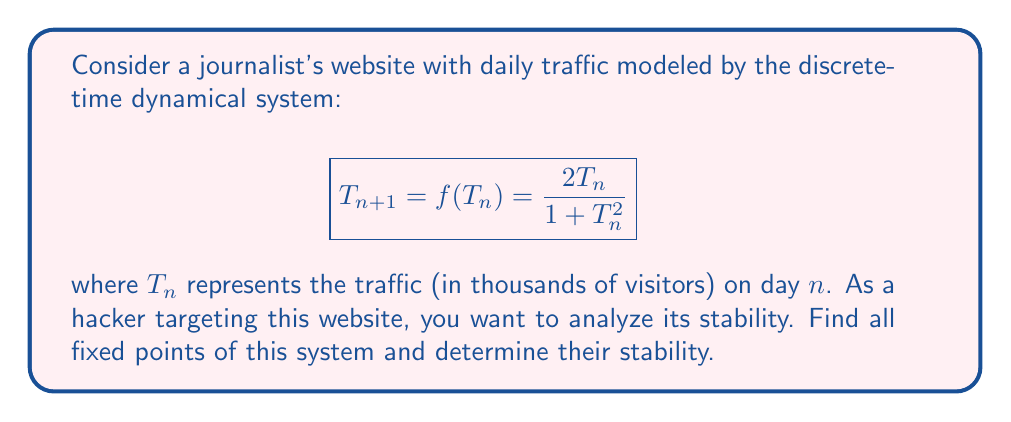Help me with this question. 1) To find the fixed points, we solve the equation $T = f(T)$:

   $$T = \frac{2T}{1 + T^2}$$

2) Multiply both sides by $(1 + T^2)$:

   $$T(1 + T^2) = 2T$$

3) Expand:

   $$T + T^3 = 2T$$

4) Subtract $2T$ from both sides:

   $$T^3 - T = 0$$

5) Factor out $T$:

   $$T(T^2 - 1) = 0$$

6) Solve:
   $T = 0$ or $T^2 = 1$, which gives $T = -1$ or $T = 1$

   So the fixed points are $T = 0, -1, 1$

7) To determine stability, we calculate $|f'(T)|$ at each fixed point:

   $$f'(T) = \frac{2(1 + T^2) - 2T(2T)}{(1 + T^2)^2} = \frac{2 - 2T^2}{(1 + T^2)^2}$$

8) At $T = 0$: $|f'(0)| = 2 > 1$, so it's unstable.

9) At $T = -1$ or $T = 1$: $|f'(\pm1)| = |\frac{2 - 2}{(1 + 1)^2}| = 0 < 1$, so they're stable.
Answer: Fixed points: 0 (unstable), -1 and 1 (stable) 